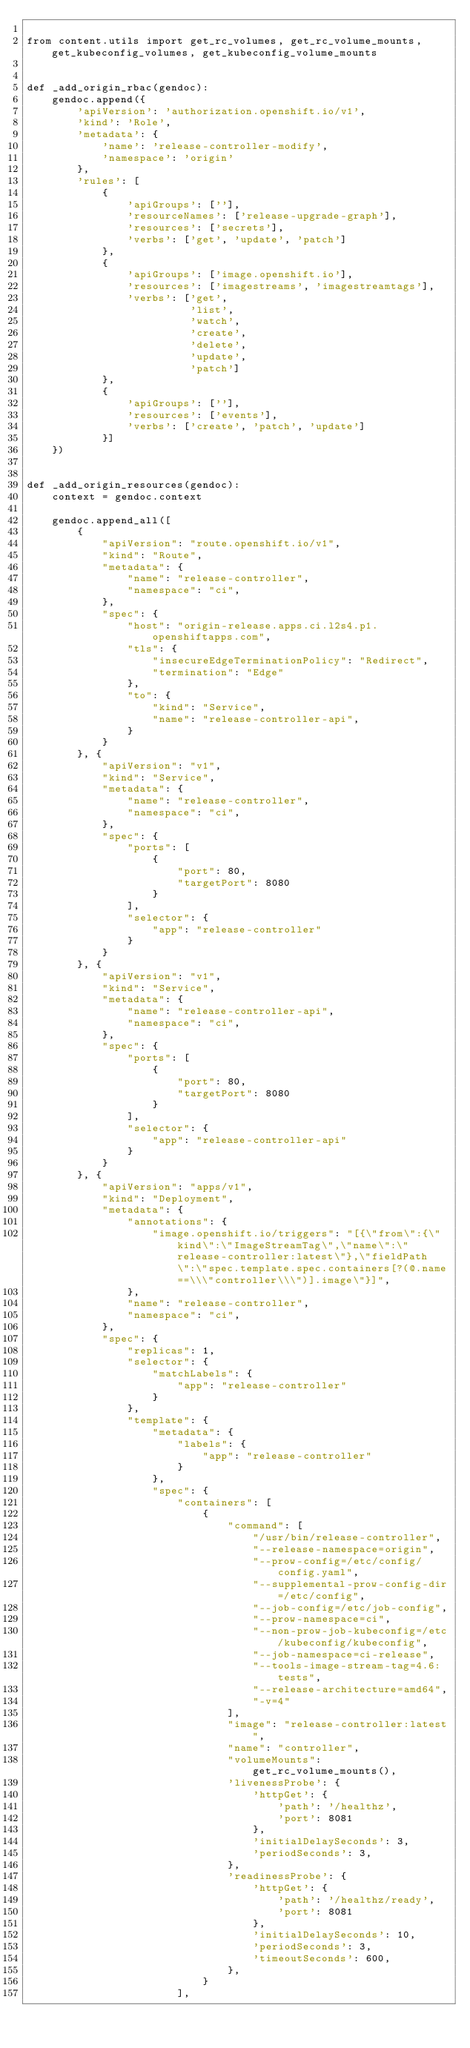Convert code to text. <code><loc_0><loc_0><loc_500><loc_500><_Python_>
from content.utils import get_rc_volumes, get_rc_volume_mounts, get_kubeconfig_volumes, get_kubeconfig_volume_mounts


def _add_origin_rbac(gendoc):
    gendoc.append({
        'apiVersion': 'authorization.openshift.io/v1',
        'kind': 'Role',
        'metadata': {
            'name': 'release-controller-modify',
            'namespace': 'origin'
        },
        'rules': [
            {
                'apiGroups': [''],
                'resourceNames': ['release-upgrade-graph'],
                'resources': ['secrets'],
                'verbs': ['get', 'update', 'patch']
            },
            {
                'apiGroups': ['image.openshift.io'],
                'resources': ['imagestreams', 'imagestreamtags'],
                'verbs': ['get',
                          'list',
                          'watch',
                          'create',
                          'delete',
                          'update',
                          'patch']
            },
            {
                'apiGroups': [''],
                'resources': ['events'],
                'verbs': ['create', 'patch', 'update']
            }]
    })


def _add_origin_resources(gendoc):
    context = gendoc.context

    gendoc.append_all([
        {
            "apiVersion": "route.openshift.io/v1",
            "kind": "Route",
            "metadata": {
                "name": "release-controller",
                "namespace": "ci",
            },
            "spec": {
                "host": "origin-release.apps.ci.l2s4.p1.openshiftapps.com",
                "tls": {
                    "insecureEdgeTerminationPolicy": "Redirect",
                    "termination": "Edge"
                },
                "to": {
                    "kind": "Service",
                    "name": "release-controller-api",
                }
            }
        }, {
            "apiVersion": "v1",
            "kind": "Service",
            "metadata": {
                "name": "release-controller",
                "namespace": "ci",
            },
            "spec": {
                "ports": [
                    {
                        "port": 80,
                        "targetPort": 8080
                    }
                ],
                "selector": {
                    "app": "release-controller"
                }
            }
        }, {
            "apiVersion": "v1",
            "kind": "Service",
            "metadata": {
                "name": "release-controller-api",
                "namespace": "ci",
            },
            "spec": {
                "ports": [
                    {
                        "port": 80,
                        "targetPort": 8080
                    }
                ],
                "selector": {
                    "app": "release-controller-api"
                }
            }
        }, {
            "apiVersion": "apps/v1",
            "kind": "Deployment",
            "metadata": {
                "annotations": {
                    "image.openshift.io/triggers": "[{\"from\":{\"kind\":\"ImageStreamTag\",\"name\":\"release-controller:latest\"},\"fieldPath\":\"spec.template.spec.containers[?(@.name==\\\"controller\\\")].image\"}]",
                },
                "name": "release-controller",
                "namespace": "ci",
            },
            "spec": {
                "replicas": 1,
                "selector": {
                    "matchLabels": {
                        "app": "release-controller"
                    }
                },
                "template": {
                    "metadata": {
                        "labels": {
                            "app": "release-controller"
                        }
                    },
                    "spec": {
                        "containers": [
                            {
                                "command": [
                                    "/usr/bin/release-controller",
                                    "--release-namespace=origin",
                                    "--prow-config=/etc/config/config.yaml",
                                    "--supplemental-prow-config-dir=/etc/config",
                                    "--job-config=/etc/job-config",
                                    "--prow-namespace=ci",
                                    "--non-prow-job-kubeconfig=/etc/kubeconfig/kubeconfig",
                                    "--job-namespace=ci-release",
                                    "--tools-image-stream-tag=4.6:tests",
                                    "--release-architecture=amd64",
                                    "-v=4"
                                ],
                                "image": "release-controller:latest",
                                "name": "controller",
                                "volumeMounts": get_rc_volume_mounts(),
                                'livenessProbe': {
                                    'httpGet': {
                                        'path': '/healthz',
                                        'port': 8081
                                    },
                                    'initialDelaySeconds': 3,
                                    'periodSeconds': 3,
                                },
                                'readinessProbe': {
                                    'httpGet': {
                                        'path': '/healthz/ready',
                                        'port': 8081
                                    },
                                    'initialDelaySeconds': 10,
                                    'periodSeconds': 3,
                                    'timeoutSeconds': 600,
                                },
                            }
                        ],</code> 